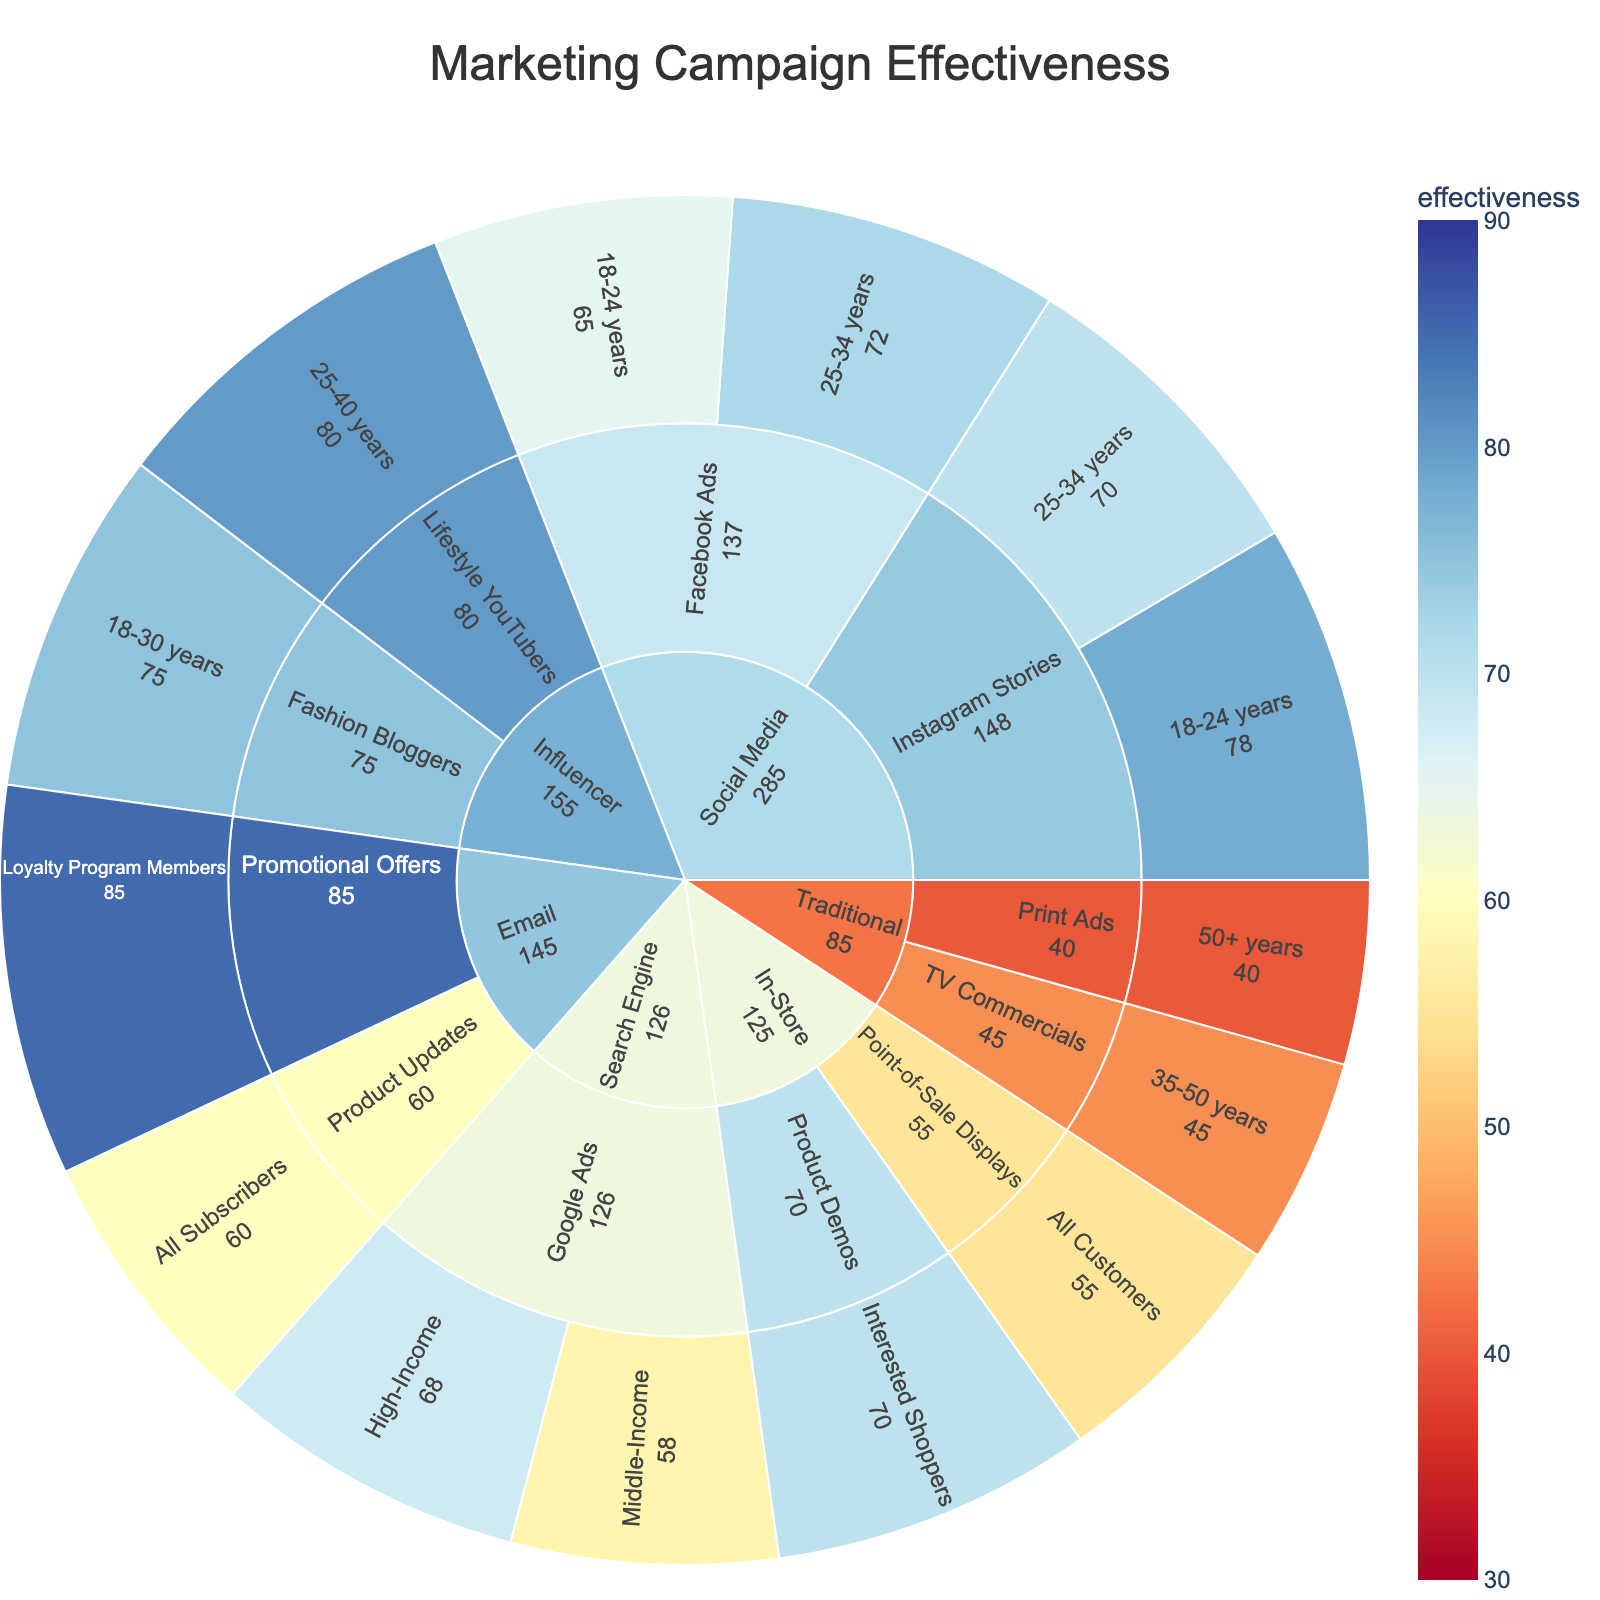Which marketing channel shows the highest effectiveness? The chart contains segments for each marketing channel. By comparing the values in the figure, we can see the highest effectiveness within the segments.
Answer: Email What is the effectiveness of Instagram Stories for the 18-24 target audience? Locate the segment for "Instagram Stories" under the "Social Media" channel, and find the value associated with the "18-24 years" audience.
Answer: 78% How does the effectiveness of Google Ads for high-income audiences compare to middle-income audiences? Find the "Google Ads" segments under the "Search Engine" channel and compare the effectiveness values for "High-Income" and "Middle-Income" audiences.
Answer: Higher for High-Income Among traditional marketing strategies, which one is more effective? Compare the effectiveness values under the "Traditional" channel for "TV Commercials" and "Print Ads" segments.
Answer: TV Commercials What is the combined effectiveness of Facebook Ads across both target audiences? Add the effectiveness values for "Facebook Ads" under "Social Media" for "18-24 years" and "25-34 years."
Answer: 137% Which audience shows higher effectiveness for Lifestyle YouTubers? Identify the segment for "Lifestyle YouTubers" under the "Influencer" channel and find the associated audience.
Answer: 25-40 years What's the difference in effectiveness between Product Updates via Email and Point-of-Sale Displays in-store campaigns? Compare the effectiveness values under the "Email" channel for "Product Updates" with the "In-Store" segment for "Point-of-Sale Displays." Calculate the difference.
Answer: 5% In the 'In-Store' marketing channel, which strategy has the highest effectiveness? Compare the effectiveness values of "Point-of-Sale Displays" and "Product Demos" under the "In-Store" channel.
Answer: Product Demos For Social Media campaigns, which strategy has the highest overall effectiveness? Compare the effectiveness values of "Facebook Ads" and "Instagram Stories" under their respective target audiences and determine the highest.
Answer: Instagram Stories 